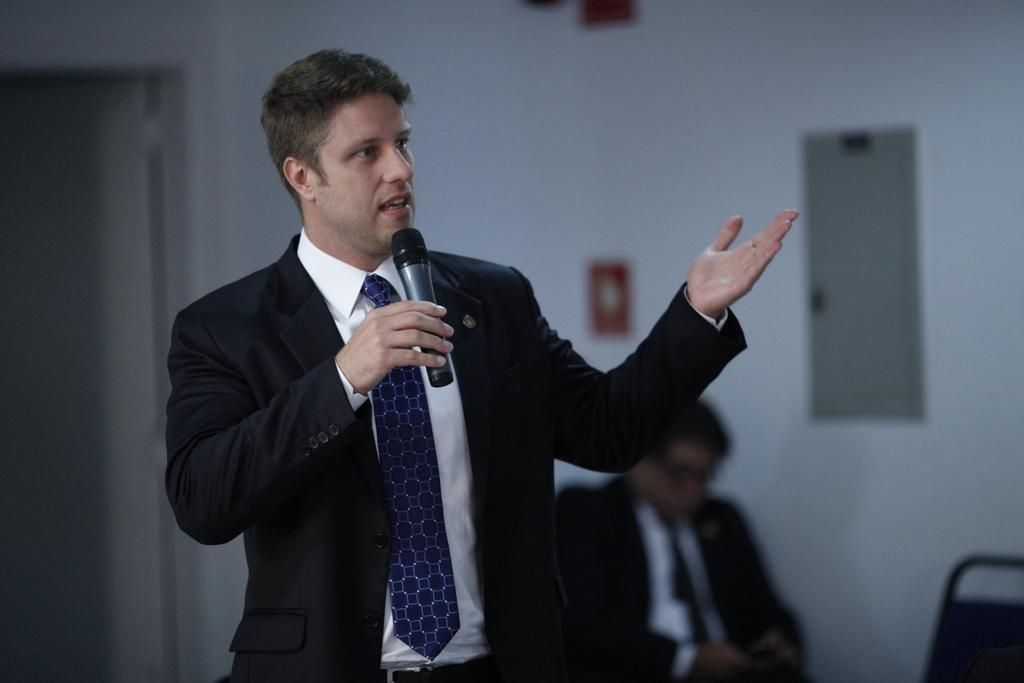What is the man in the image doing with his hands? The man is holding a microphone in the image. What is the man doing with the microphone? The man is speaking into the microphone. Can you describe the position of the other man in the image? There is another man sitting in the image. What type of wool is being spun by the man in the image? There is no wool or spinning activity present in the image. How many roses can be seen on the table in the image? There is no table or roses present in the image. 